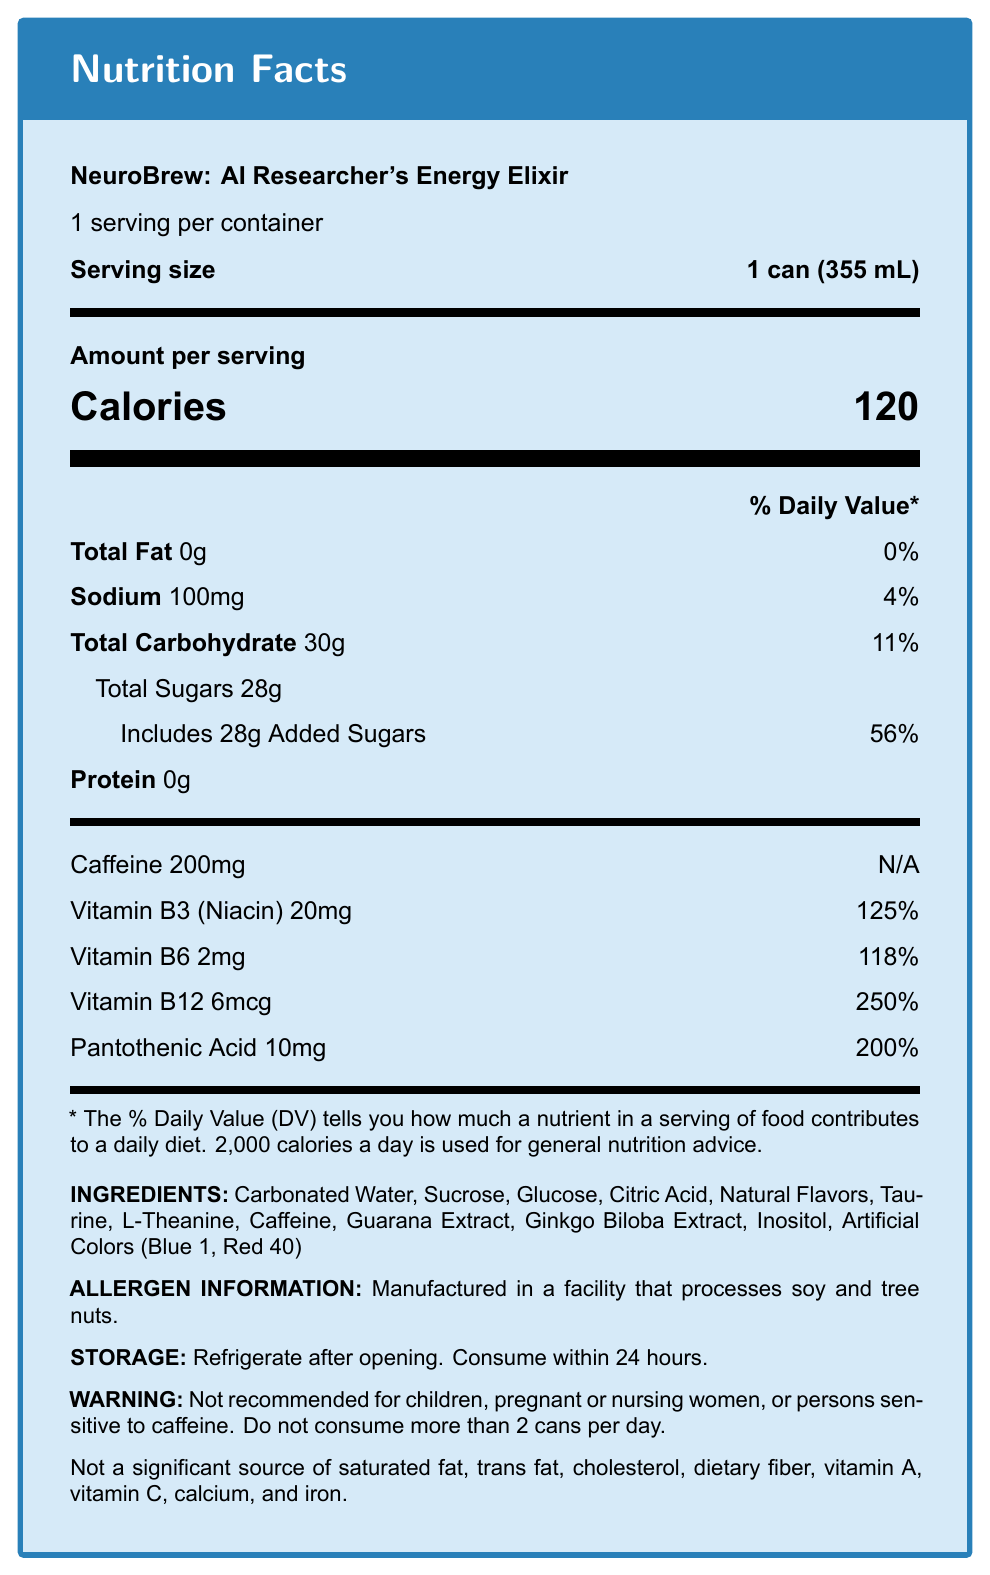what is the serving size of NeuroBrew? The serving size is specified as "1 can (355 mL)" in the document.
Answer: 1 can (355 mL) how many calories are in one serving of NeuroBrew? The document states that there are 120 calories in one serving.
Answer: 120 how much caffeine is in one serving of NeuroBrew? The caffeine content is listed as 200mg under the nutritional information.
Answer: 200mg what percentage of the daily value of Vitamin B12 does a serving of NeuroBrew provide? The document lists the % Daily Value of Vitamin B12 as 250%.
Answer: 250% which vitamins and their quantities are included in NeuroBrew? These quantities are provided in the "vitamins_and_minerals" section of the document.
Answer: Vitamin B3 (Niacin) 20mg, Vitamin B6 2mg, Vitamin B12 6mcg, Pantothenic Acid 10mg what is the total carbohydrate content per serving? The total carbohydrate content per serving is listed as 30g in the document.
Answer: 30g what are the main cognitive enhancers included in NeuroBrew? A. Creatine and Ginseng B. L-Theanine and Ginkgo Biloba C. Omega-3 and Choline D. Iron and Zinc The document mentions that NeuroBrew contains cognitive enhancers like L-Theanine and Ginkgo Biloba.
Answer: B how many servings per container does NeuroBrew have? A. 2 B. 3 C. 1 D. 4 The document states, "1 serving per container", indicating one serving per container.
Answer: C is NeuroBrew recommended for children? The warnings section states "Not recommended for children".
Answer: No describe the main idea of the document. This summary covers the product's purpose, key ingredients, and nutritional facts, along with warnings and additional information.
Answer: NeuroBrew: AI Researcher's Energy Elixir is an energy drink formulated to support mental clarity and focus during long coding sessions. It has a unique blend of caffeine, B-vitamins, and cognitive enhancers like L-Theanine and Ginkgo Biloba. The detailed nutritional information, ingredients, allergen information, and usage warnings are all provided in the document. does the document mention the amount of Vitamin C in NeuroBrew? The document specifies that Vitamin C is not a significant source in NeuroBrew. Thus, no amount for Vitamin C is listed.
Answer: No, it does not mention Vitamin C. 